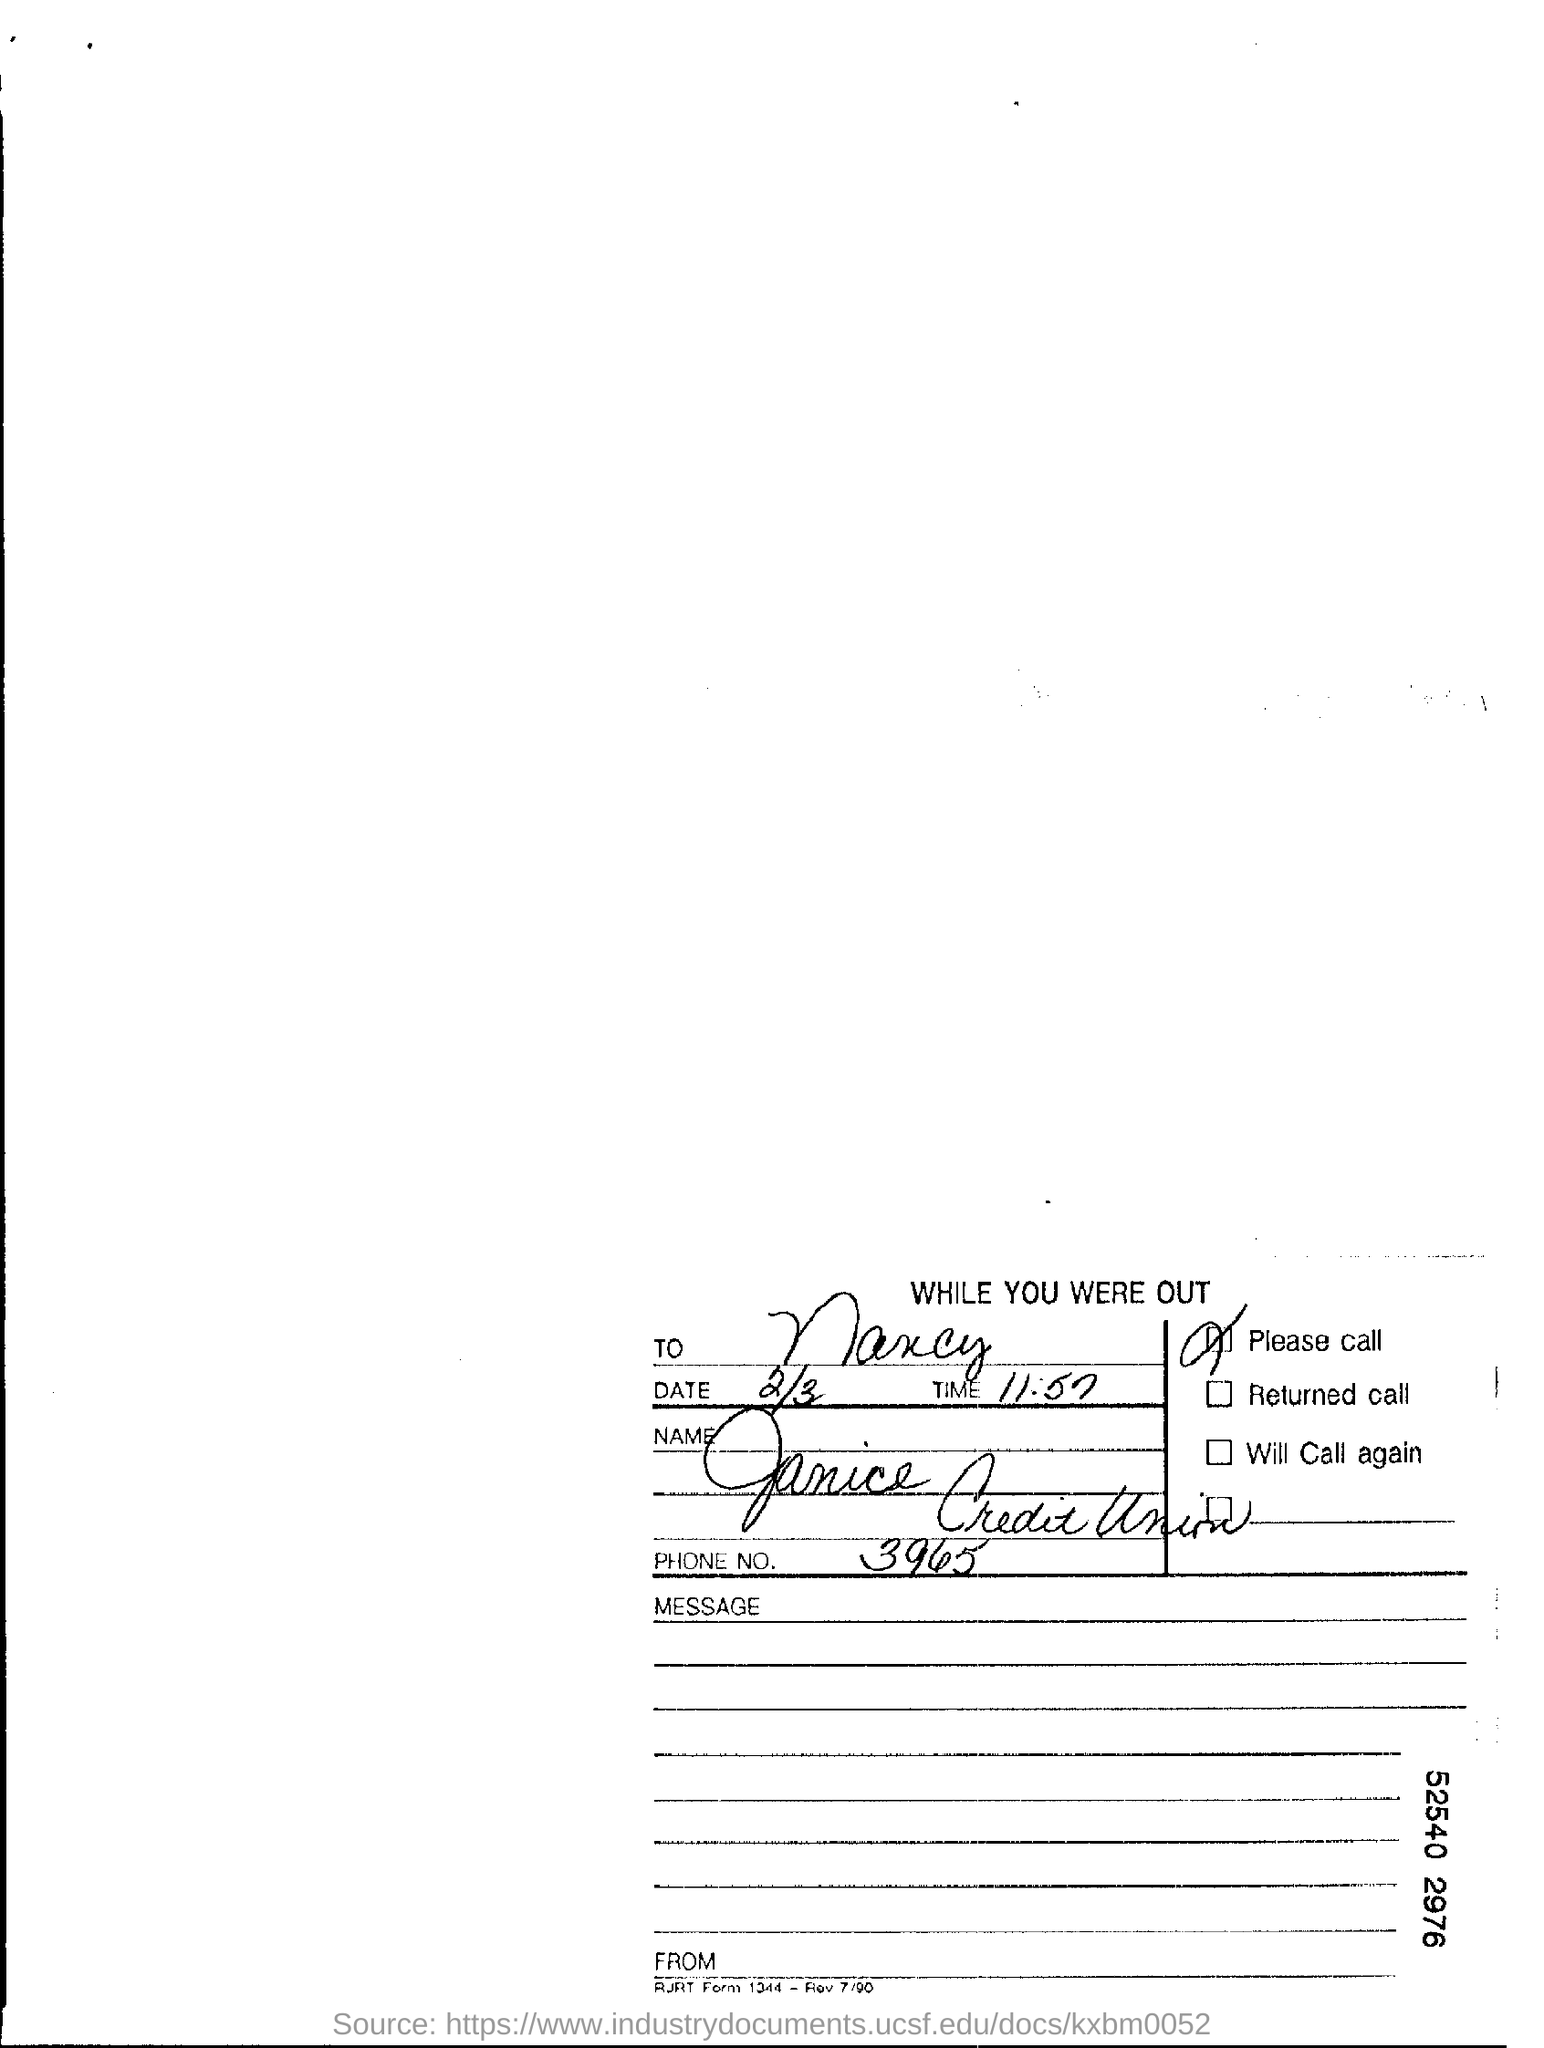Point out several critical features in this image. The date is February 3rd. It is currently 11:57. I would like to know the phone number. It is 3965..., 